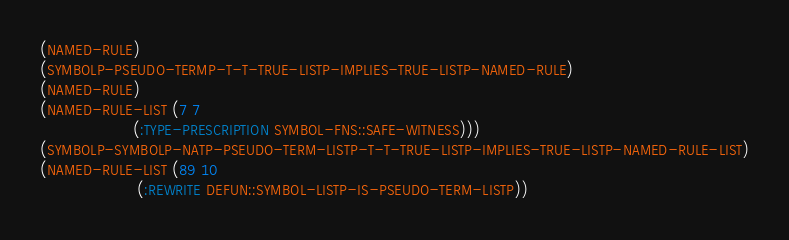<code> <loc_0><loc_0><loc_500><loc_500><_Lisp_>(NAMED-RULE)
(SYMBOLP-PSEUDO-TERMP-T-T-TRUE-LISTP-IMPLIES-TRUE-LISTP-NAMED-RULE)
(NAMED-RULE)
(NAMED-RULE-LIST (7 7
                    (:TYPE-PRESCRIPTION SYMBOL-FNS::SAFE-WITNESS)))
(SYMBOLP-SYMBOLP-NATP-PSEUDO-TERM-LISTP-T-T-TRUE-LISTP-IMPLIES-TRUE-LISTP-NAMED-RULE-LIST)
(NAMED-RULE-LIST (89 10
                     (:REWRITE DEFUN::SYMBOL-LISTP-IS-PSEUDO-TERM-LISTP))</code> 